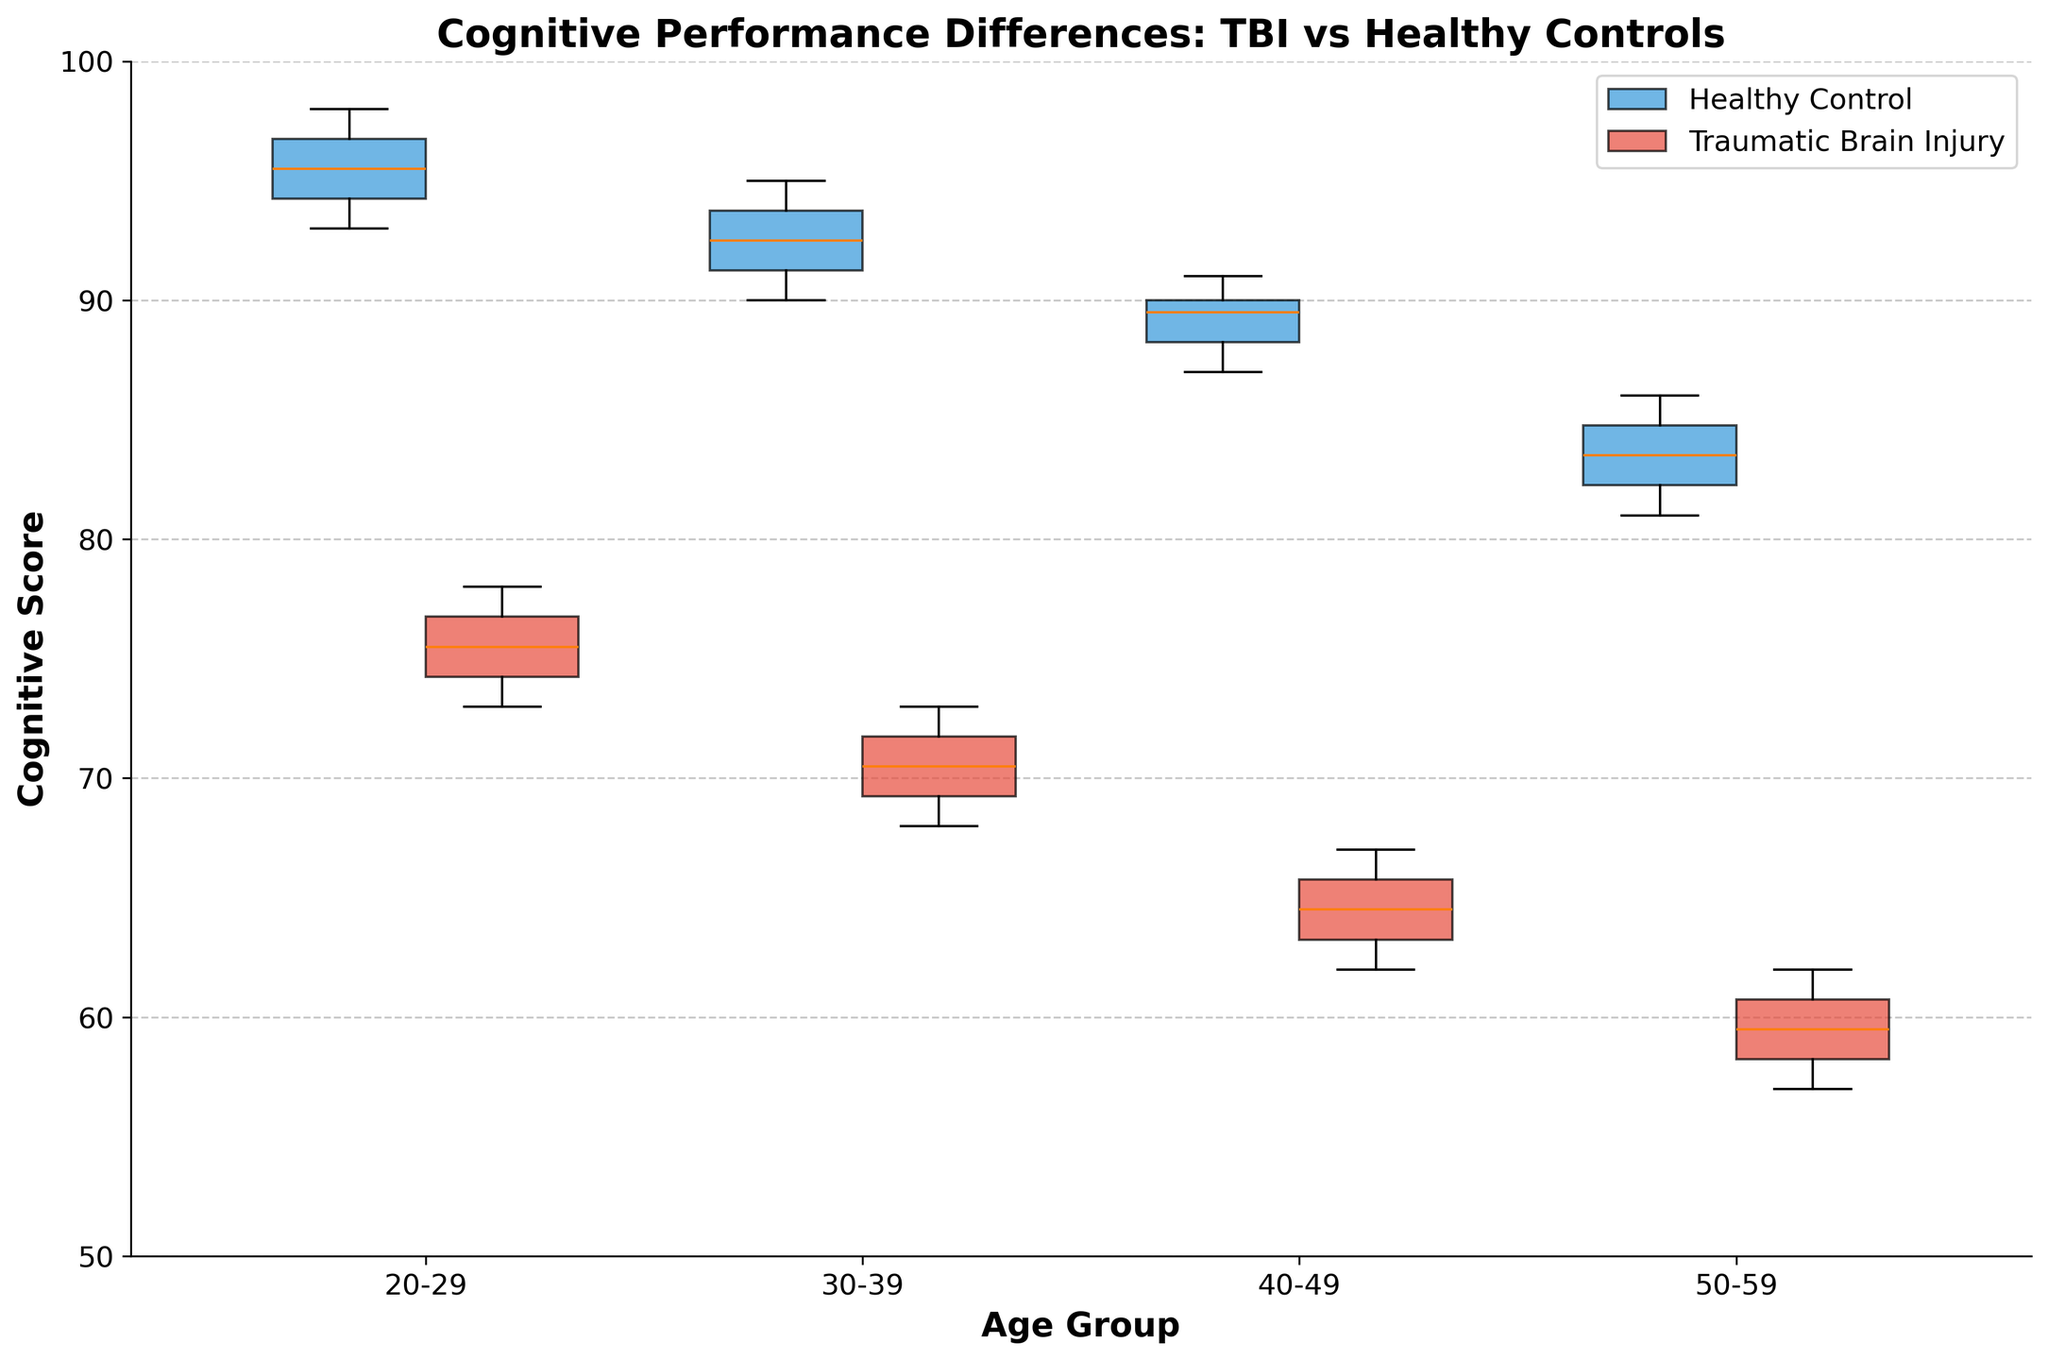What is the title of the plot? The title is usually found at the top-center of the plot and provides an overview of what the plot represents. In this plot, it reads "Cognitive Performance Differences: TBI vs Healthy Controls".
Answer: Cognitive Performance Differences: TBI vs Healthy Controls What are the age groups compared in the plot? The age groups are shown along the x-axis at the bottom of the plot. They are labeled as 20-29, 30-39, 40-49, and 50-59.
Answer: 20-29, 30-39, 40-49, 50-59 Which group generally has higher cognitive scores, Healthy Controls or Traumatic Brain Injury? By observing the central tendency (medians and means) and the placement of the boxes, it is evident that the cognitive scores of the Healthy Controls are higher across all age groups compared to those with Traumatic Brain Injury.
Answer: Healthy Controls What's the median cognitive score for the 50-59 age group in Healthy Controls? The median is represented by the line inside each box. For the 50-59 age group in Healthy Controls, the line inside the blue box indicates the median score is 84.5.
Answer: 84.5 By how much does the median cognitive score differ between the 20-29 age group of Healthy Controls and Traumatic Brain Injury patients? The median score for Healthy Controls (20-29) is around 95, while for TBI patients it is approximately 75. The difference is 95 - 75 = 20 points.
Answer: 20 points Which age group has the widest range of cognitive scores among Healthy Controls? The range is represented by the length of the whiskers (from minimum to maximum). In Healthy Controls, the 20-29 age group exhibits the widest range as the whiskers span the largest distance.
Answer: 20-29 Does the cognitive score range for Traumatic Brain Injury patients shrink with increasing age groups? To determine this, one must compare the distance between the whiskers for each age group of Traumatic Brain Injury patients. The range shrinks as one moves from the 20-29 age group to the 50-59 age group.
Answer: Yes What is the interquartile range (IQR) of cognitive scores for Healthy Controls in the 30-39 age group? Calculate the difference between Q3 and Q1. The IQR is the range between the top and bottom of the box (Q3-Q1). For the Healthy Controls in the 30-39 age group, Q3 is about 94, and Q1 is about 91, so the IQR is 94 - 91 = 3.
Answer: 3 Compare the means of cognitive scores between Healthy Controls and Traumatic Brain Injury patients in the 40-49 age group. From the central tendency indicated in each box, the mean score for Healthy Controls in the 40-49 age group hovers around 89.5, while for TBI patients, it is around 64.5.
Answer: 89.5 (Healthy Controls), 64.5 (TBI) Are there any outliers present in the cognitive scores for any group or age category? Outliers are typically represented by dots outside the whiskers. By viewing the plot, no outliers are observable in any of the age groups for either Healthy Controls or Traumatic Brain Injury groups.
Answer: No 